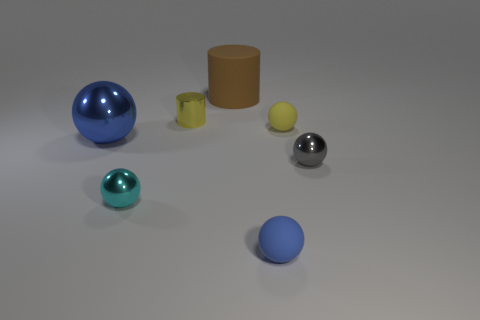Subtract all blue spheres. How many were subtracted if there are1blue spheres left? 1 Subtract 2 balls. How many balls are left? 3 Subtract all blue metal spheres. How many spheres are left? 4 Subtract all yellow spheres. How many spheres are left? 4 Subtract all green balls. Subtract all gray blocks. How many balls are left? 5 Add 1 green things. How many objects exist? 8 Subtract all spheres. How many objects are left? 2 Add 4 yellow spheres. How many yellow spheres exist? 5 Subtract 0 cyan cylinders. How many objects are left? 7 Subtract all big gray shiny balls. Subtract all small yellow shiny objects. How many objects are left? 6 